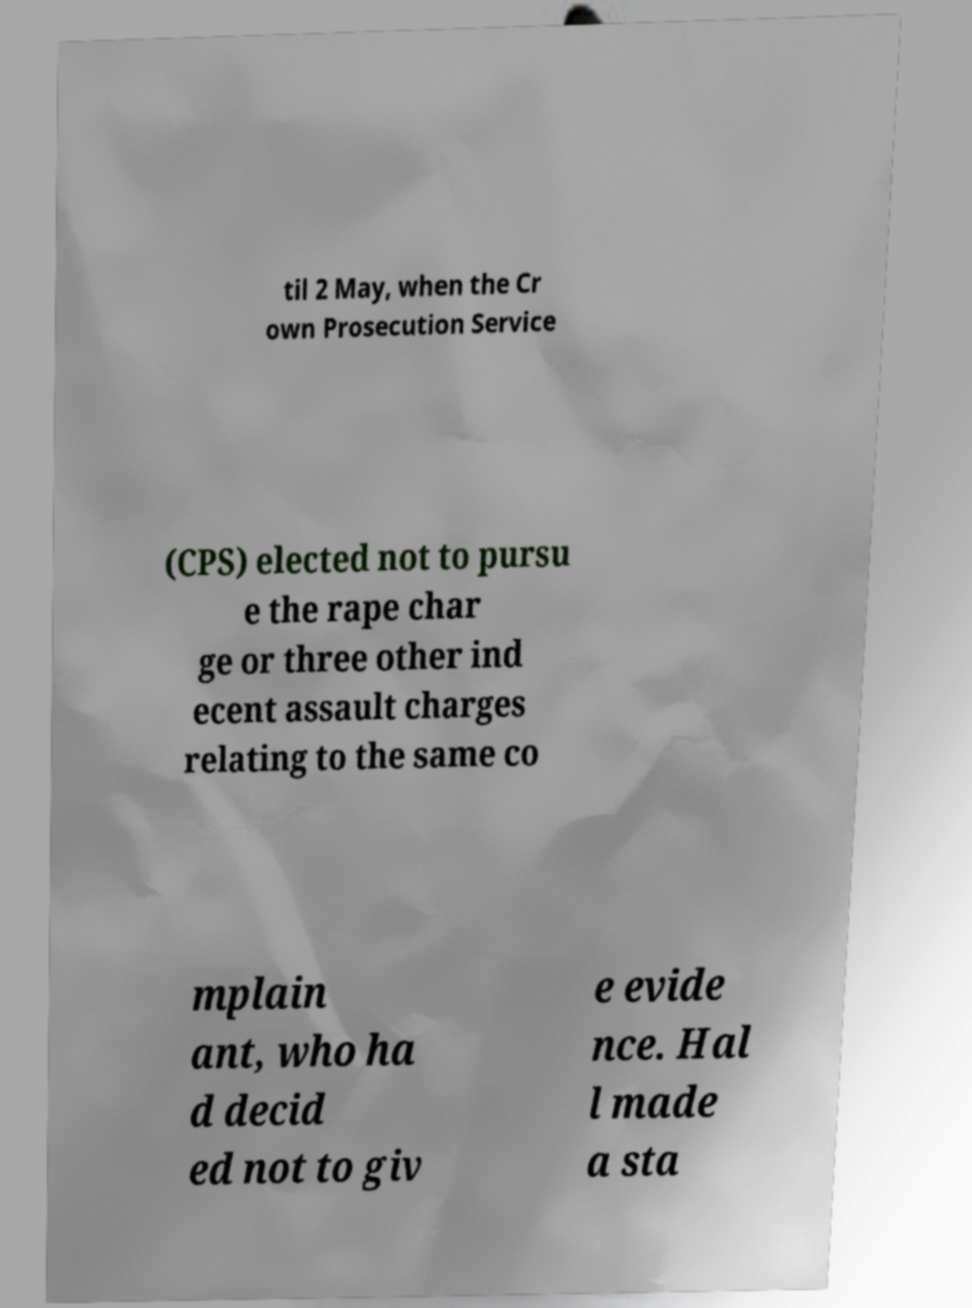There's text embedded in this image that I need extracted. Can you transcribe it verbatim? til 2 May, when the Cr own Prosecution Service (CPS) elected not to pursu e the rape char ge or three other ind ecent assault charges relating to the same co mplain ant, who ha d decid ed not to giv e evide nce. Hal l made a sta 